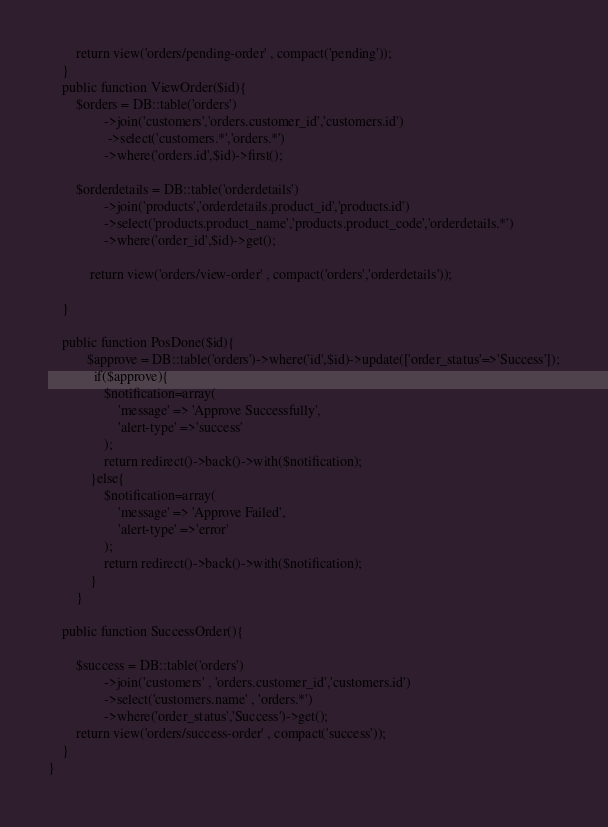Convert code to text. <code><loc_0><loc_0><loc_500><loc_500><_PHP_>    	return view('orders/pending-order' , compact('pending'));
    }
    public function ViewOrder($id){
    	$orders = DB::table('orders')
    			->join('customers','orders.customer_id','customers.id')
    			 ->select('customers.*','orders.*')
    			->where('orders.id',$id)->first();

    	$orderdetails = DB::table('orderdetails')
    			->join('products','orderdetails.product_id','products.id')
    			->select('products.product_name','products.product_code','orderdetails.*')
    			->where('order_id',$id)->get();

			return view('orders/view-order' , compact('orders','orderdetails'));

    }

    public function PosDone($id){
    	   $approve = DB::table('orders')->where('id',$id)->update(['order_status'=>'Success']);
    	     if($approve){
                $notification=array(
                    'message' => 'Approve Successfully',
                    'alert-type' =>'success'
                );
                return redirect()->back()->with($notification);
            }else{
            	$notification=array(
                    'message' => 'Approve Failed',
                    'alert-type' =>'error'
                );
                return redirect()->back()->with($notification);
            }
		}

    public function SuccessOrder(){

    	$success = DB::table('orders')
    			->join('customers' , 'orders.customer_id','customers.id')
    			->select('customers.name' , 'orders.*')
    			->where('order_status','Success')->get();
    	return view('orders/success-order' , compact('success'));
    }
}
</code> 